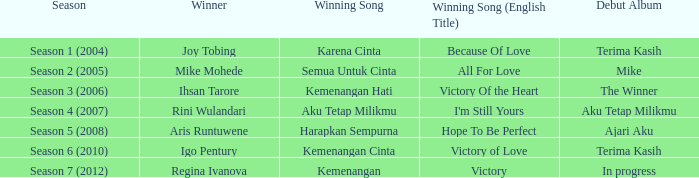Which album debuted in season 2 (2005)? Mike. 